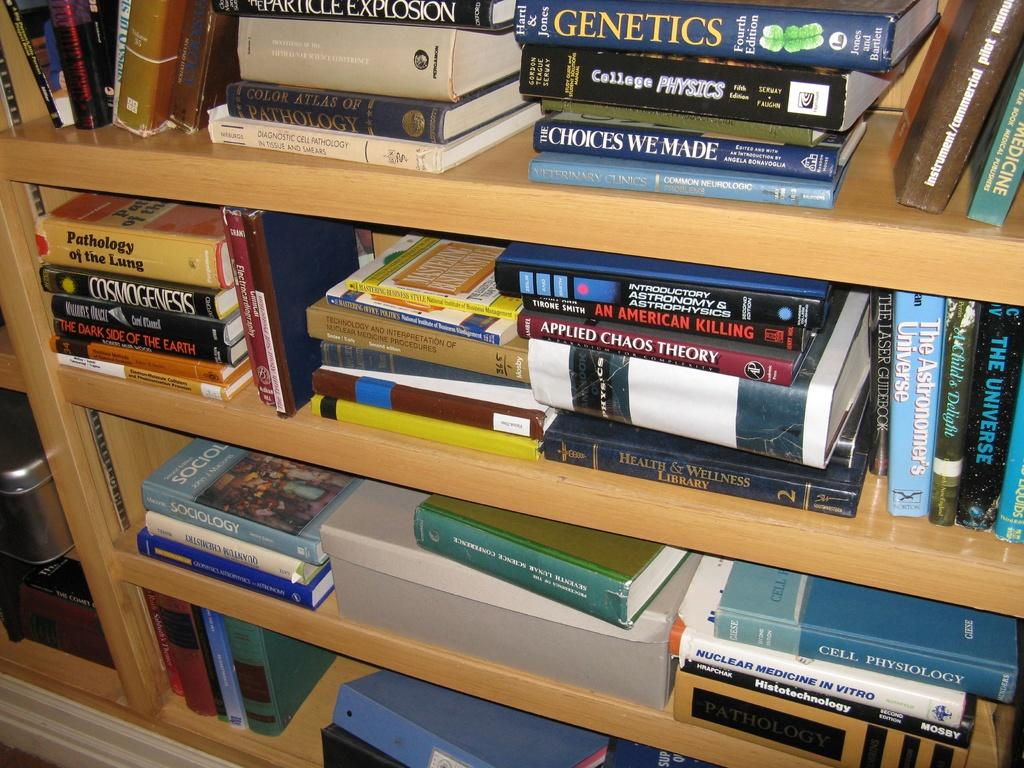<image>
Present a compact description of the photo's key features. Shelves with many books including College Physics, Applied Chaos Theory, and Nuclear Medicine In Vitro. 